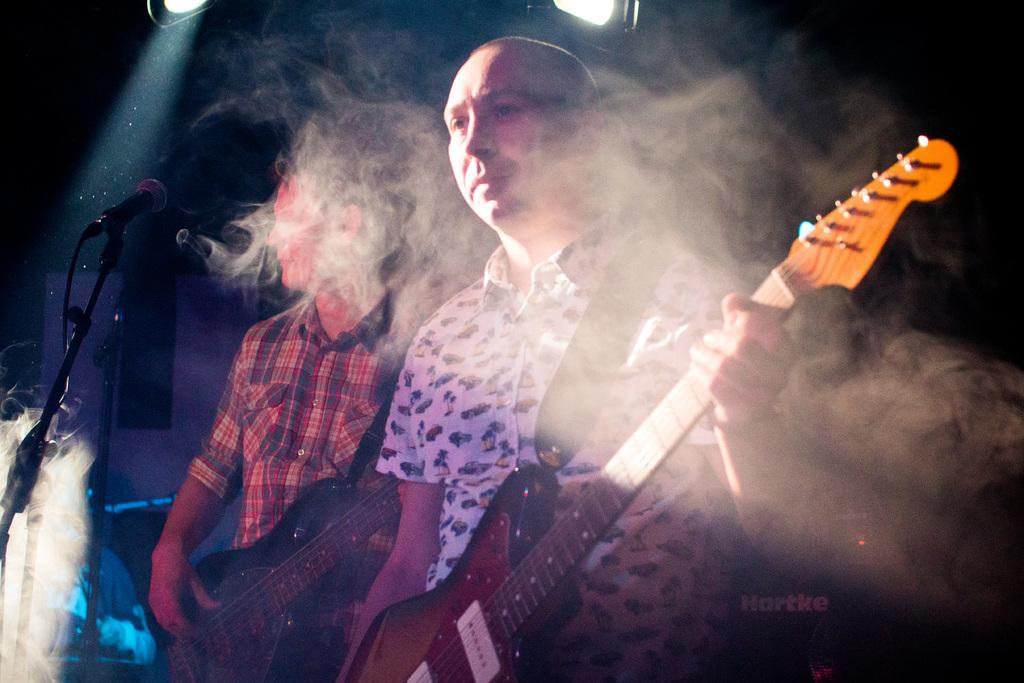How many people are in the image? There are two persons in the image. What are the two persons doing? Both persons are playing guitar. What object is present in front of the two persons? There is a microphone in front of the two persons. What type of doll can be seen holding a brick in the image? There is no doll or brick present in the image. 